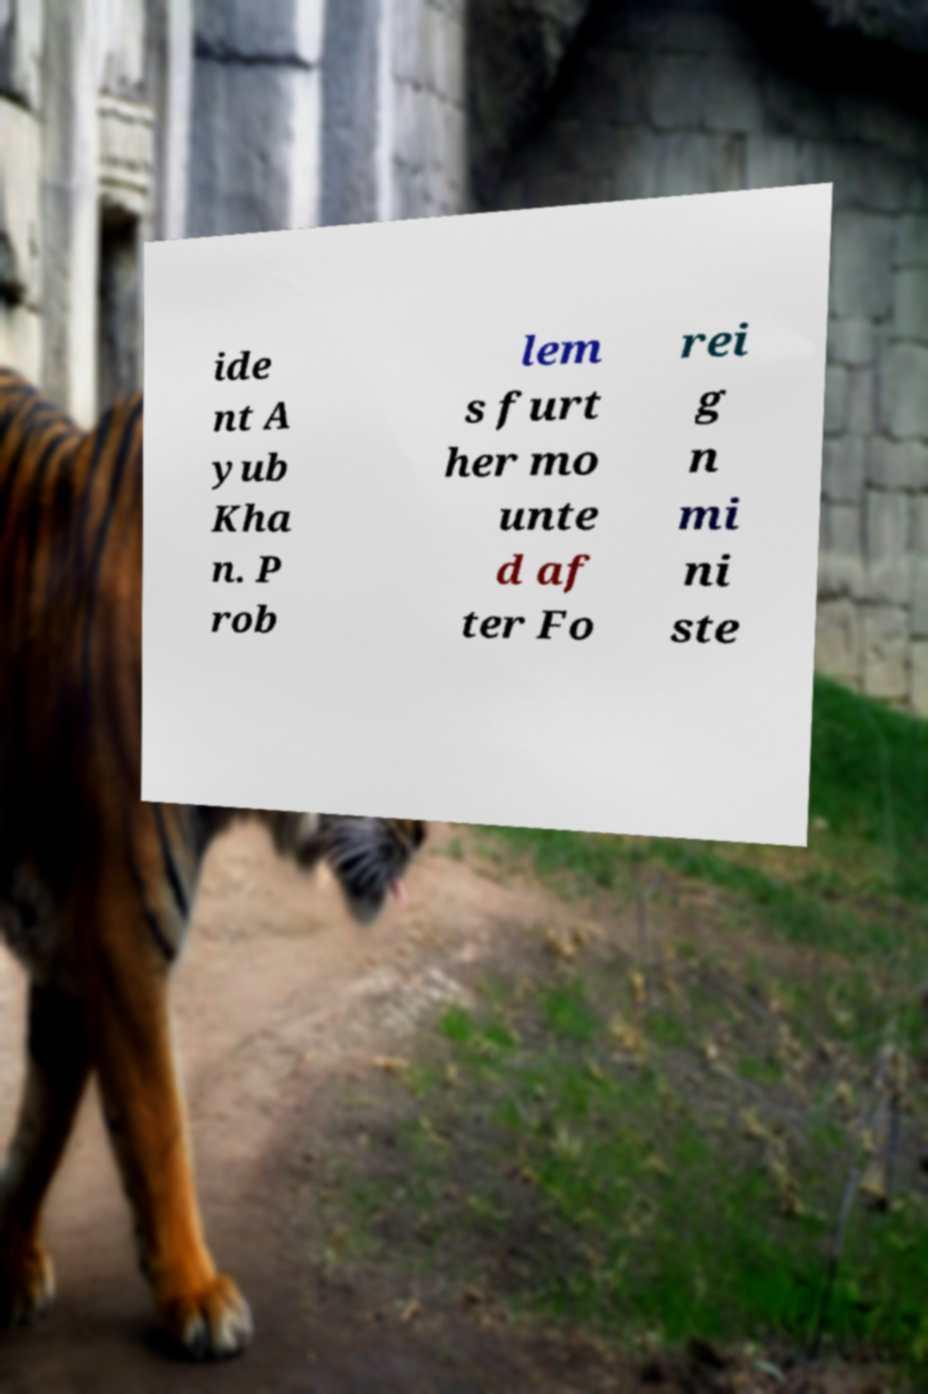Please identify and transcribe the text found in this image. ide nt A yub Kha n. P rob lem s furt her mo unte d af ter Fo rei g n mi ni ste 